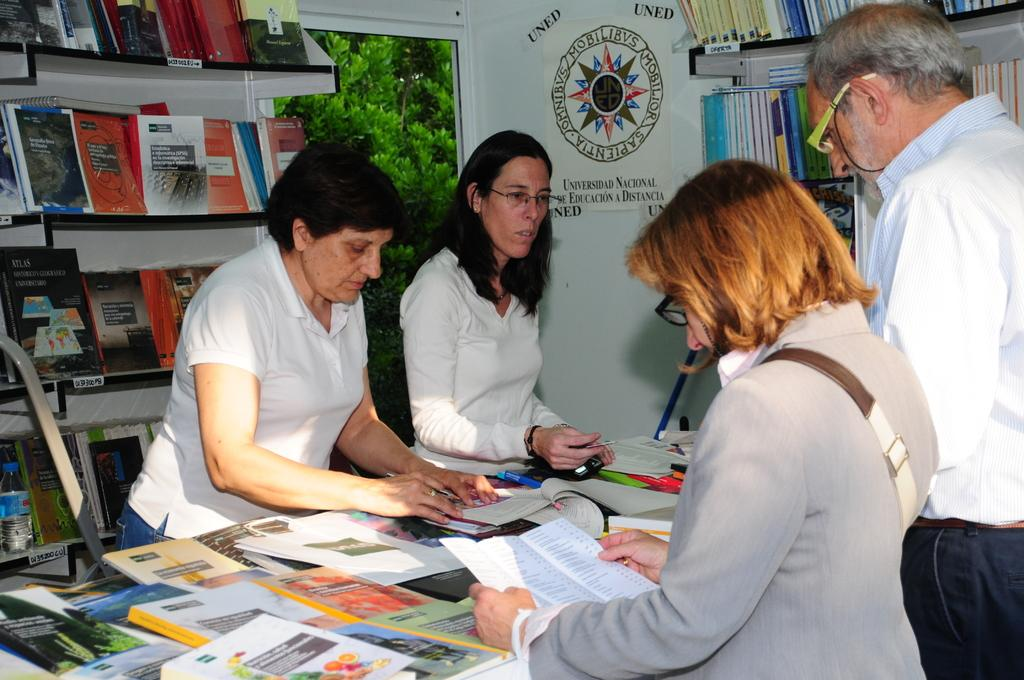<image>
Summarize the visual content of the image. Four people are standing in front of a sign for the Universidad National De Educacion A Distancia. 